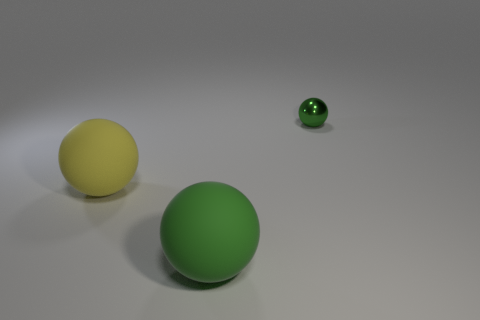The green object that is made of the same material as the yellow ball is what shape?
Provide a short and direct response. Sphere. There is a rubber thing behind the rubber thing that is to the right of the yellow thing; what is its color?
Provide a succinct answer. Yellow. There is another large object that is the same shape as the big yellow thing; what is its material?
Your answer should be compact. Rubber. Is there a large yellow object right of the sphere on the left side of the green ball in front of the tiny green metallic object?
Your answer should be compact. No. Is the shape of the green rubber thing the same as the green thing behind the yellow rubber sphere?
Keep it short and to the point. Yes. Is the color of the big matte object that is behind the large green sphere the same as the large matte ball right of the yellow matte thing?
Ensure brevity in your answer.  No. Are there any tiny cyan cubes?
Keep it short and to the point. No. Is there a gray cylinder that has the same material as the large yellow sphere?
Make the answer very short. No. Is there anything else that has the same material as the tiny object?
Offer a very short reply. No. What color is the small object?
Ensure brevity in your answer.  Green. 